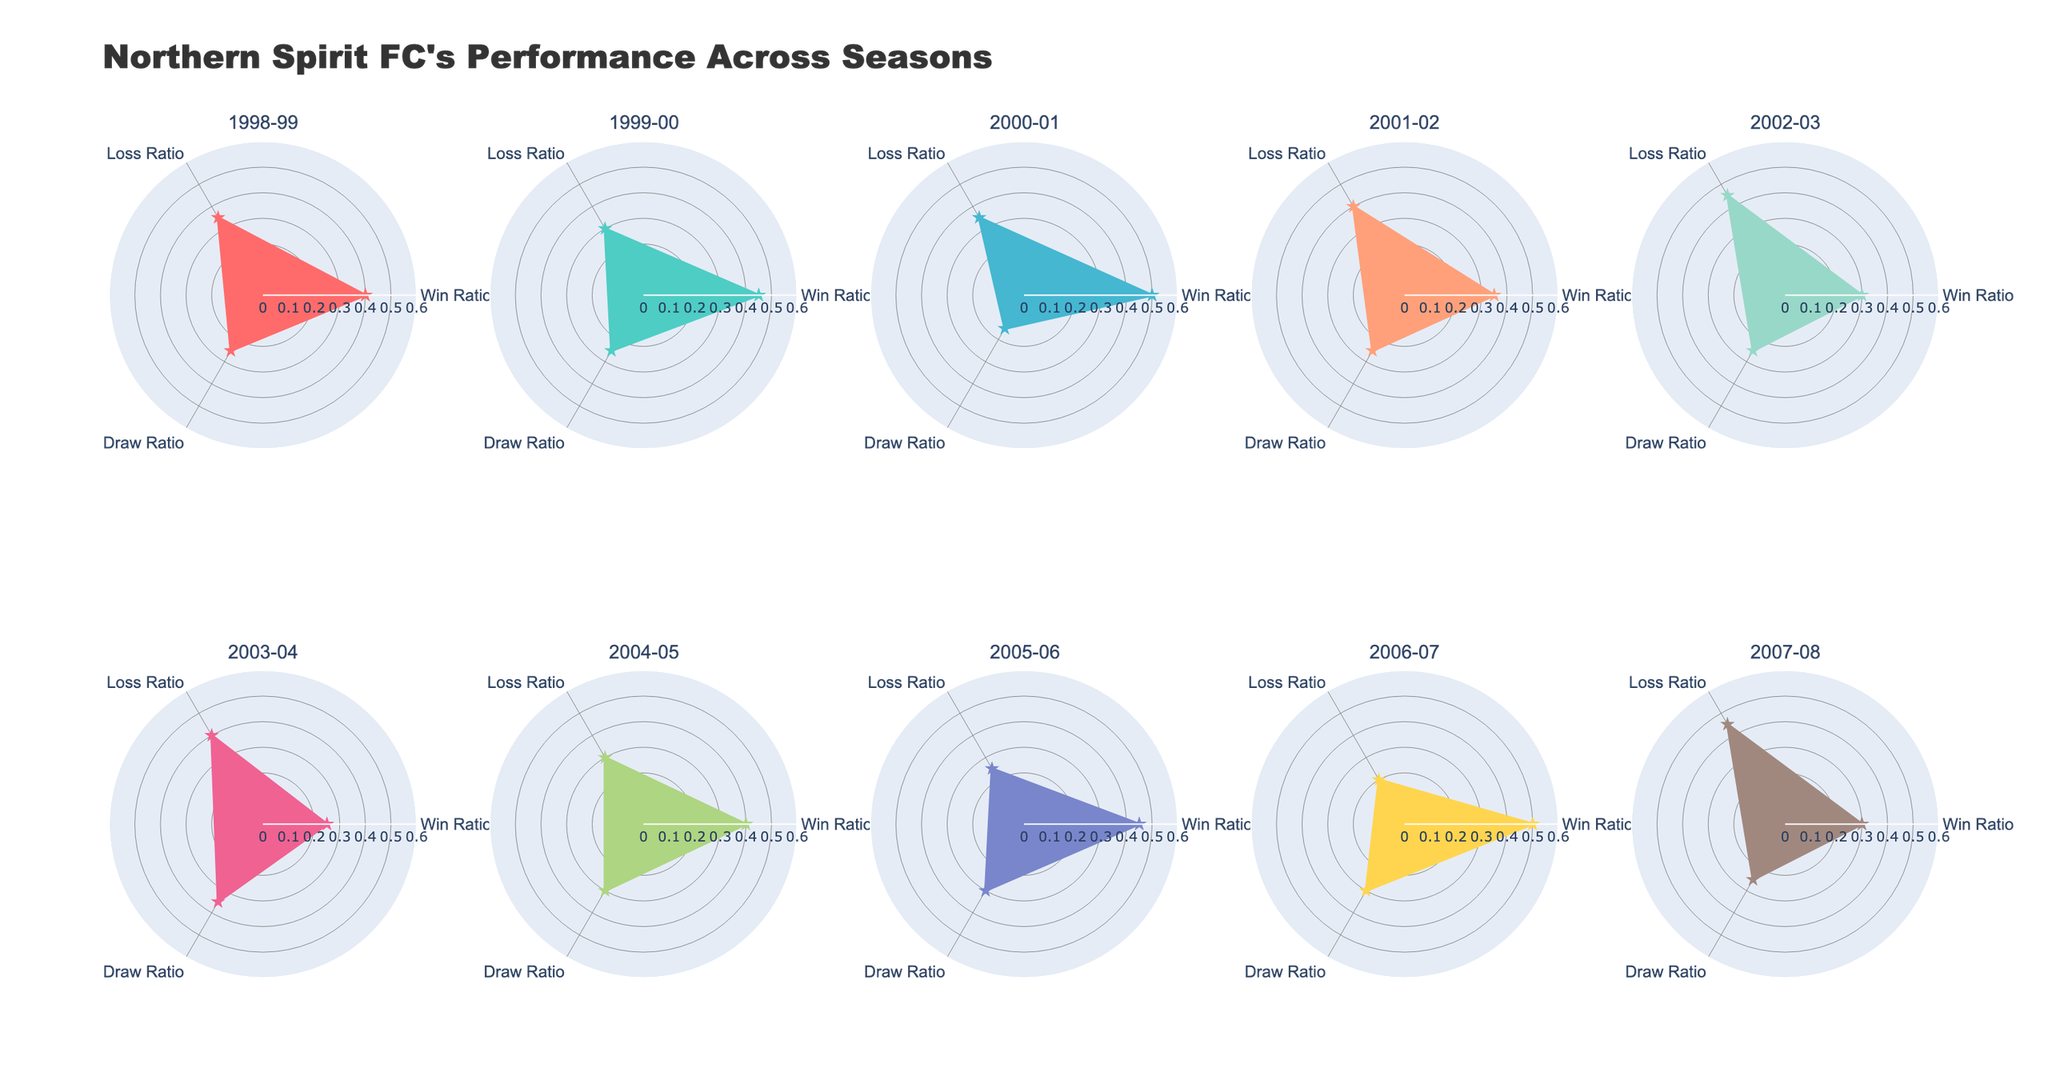What is the win ratio for the 2000-01 season? The win ratio can be directly read from the 2000-01 season plot, which shows a point on the radar chart indicating the win ratio.
Answer: 0.50 Which season has the highest draw ratio? By visually comparing the draw ratios of all the seasons, the 2003-04 season has the largest draw section on the radar chart.
Answer: 2003-04 Compare the loss ratios for the 1998-99 and 2006-07 seasons. Which is higher? The loss ratio for each season is represented on the radar chart, with 1998-99 having a loss ratio of 0.35 and 2006-07 having a loss ratio of 0.20.
Answer: 1998-99 During the 2005-06 season, what is the difference between the win and draw ratios? The win ratio for 2005-06 is 0.45, and the draw ratio is 0.30. The difference is 0.45 - 0.30.
Answer: 0.15 What is the average win ratio across the 1998-99, 1999-00, and 2000-01 seasons? Adding the win ratios and dividing by the number of seasons: (0.40 + 0.45 + 0.50) / 3.
Answer: 0.45 Which season has the smallest win ratio, and what is it? The smallest win ratio can be found by inspecting each season's chart section for win ratios. The 2003-04 season has the smallest win ratio segment.
Answer: 2003-04, 0.25 Are there any seasons where the draw ratio remains constant? By inspecting the radar charts, the draw ratios for the 1998-99, 1999-00, 2001-02, 2002-03, and 2007-08 seasons are all 0.25.
Answer: Yes, 0.25 Which seasons have a higher win ratio than loss ratio? By visually comparing the win and loss ratios for every season, it is apparent that 1998-99, 1999-00, 2000-01, 2004-05, 2005-06, and 2006-07 seasons fit this criterion.
Answer: 1998-99, 1999-00, 2000-01, 2004-05, 2005-06, 2006-07 In which season is the contrast between win ratio and loss ratio most significant? For this, compare the differences between win and loss ratios for all seasons. The 2006-07 season has the win ratio of 0.50 and a loss ratio of 0.20, making a contrast of 0.30.
Answer: 2006-07 